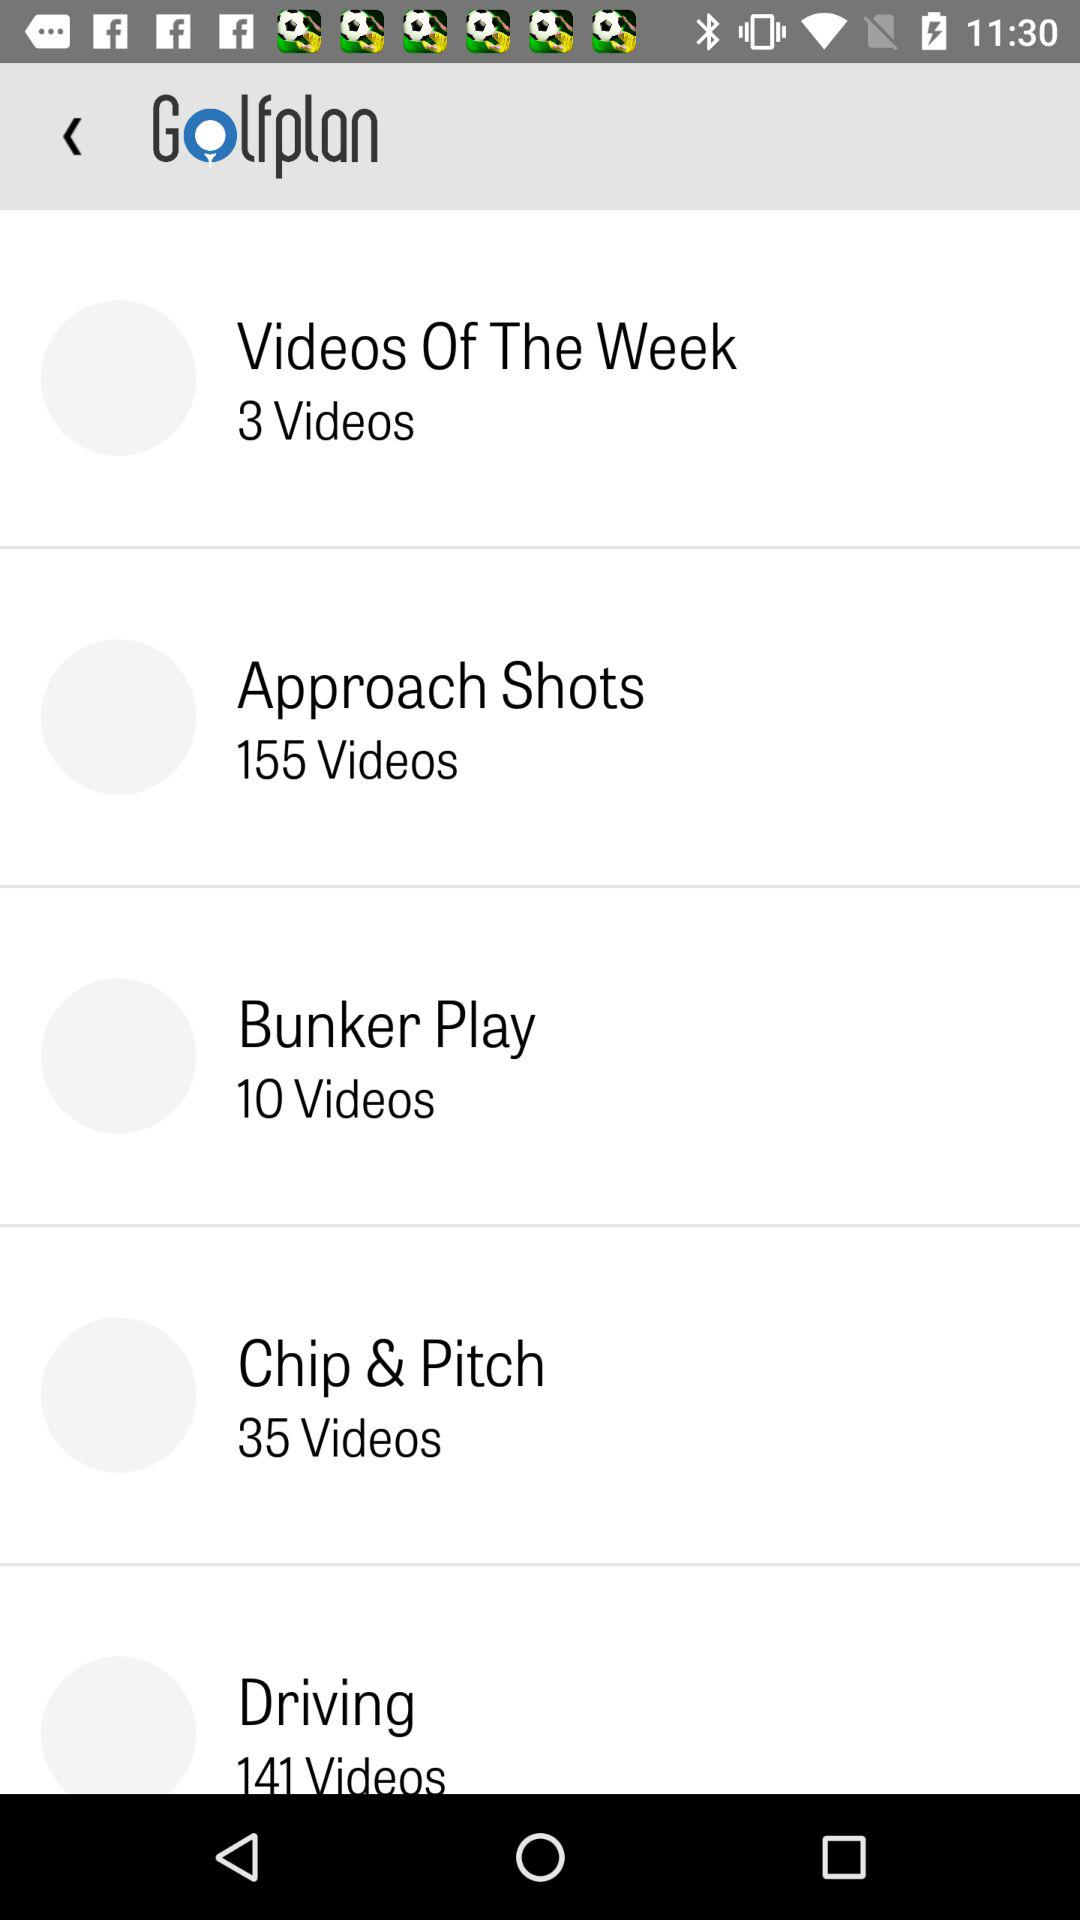How many videos are there in the approach shots? There are 155 videos. 